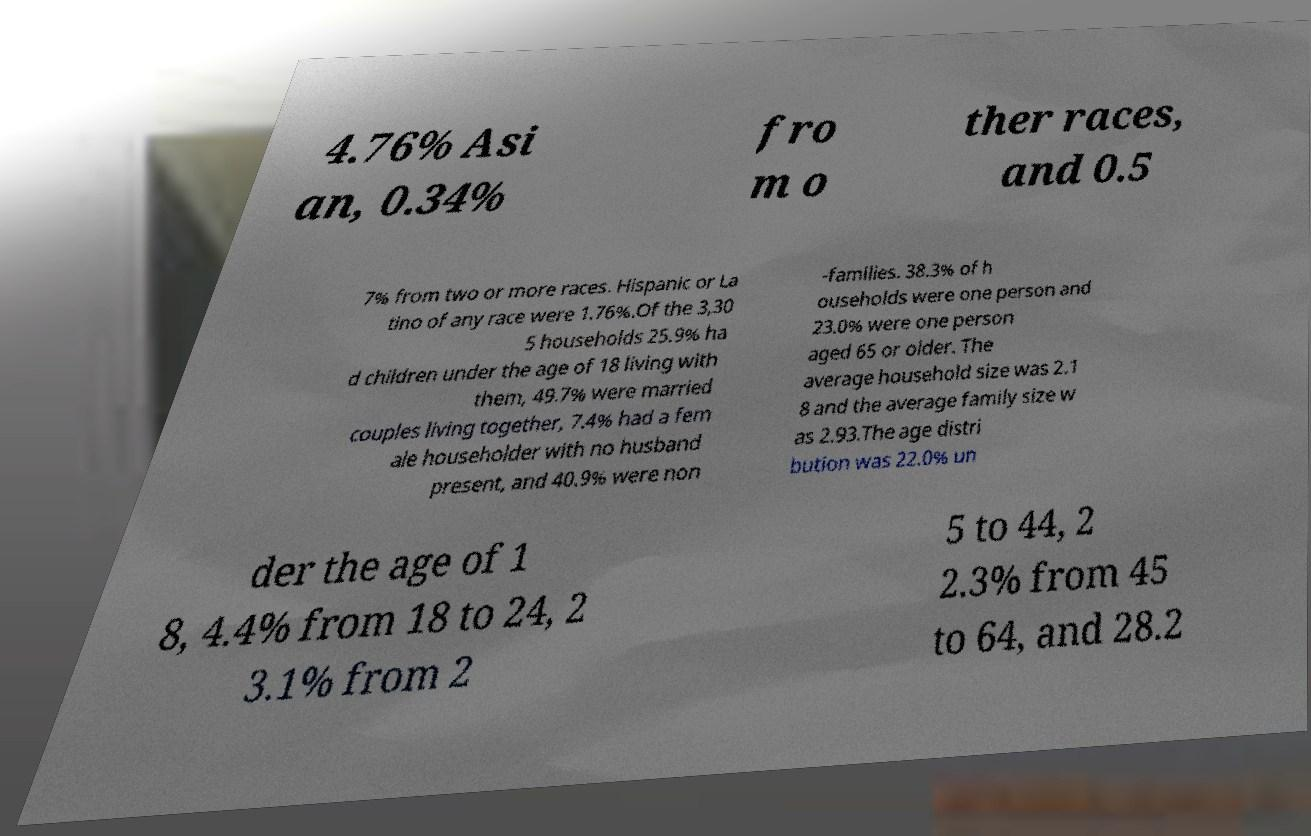Can you accurately transcribe the text from the provided image for me? 4.76% Asi an, 0.34% fro m o ther races, and 0.5 7% from two or more races. Hispanic or La tino of any race were 1.76%.Of the 3,30 5 households 25.9% ha d children under the age of 18 living with them, 49.7% were married couples living together, 7.4% had a fem ale householder with no husband present, and 40.9% were non -families. 38.3% of h ouseholds were one person and 23.0% were one person aged 65 or older. The average household size was 2.1 8 and the average family size w as 2.93.The age distri bution was 22.0% un der the age of 1 8, 4.4% from 18 to 24, 2 3.1% from 2 5 to 44, 2 2.3% from 45 to 64, and 28.2 